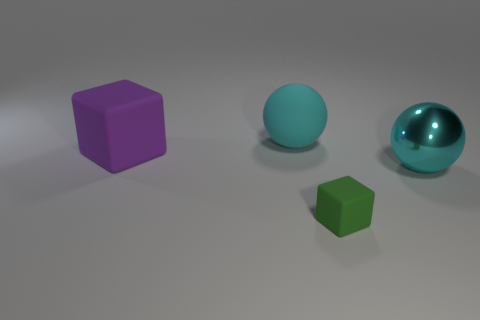If I were to push the green cube, how might it interact with the other objects? Considering the positioning and apparent sizes of the objects, if you pushed the green cube, it might roll or slide on the surface. Depending on the force of the push and the cube's trajectory, it could potentially come into contact with the larger teal ball, possibly altering its position slightly. 